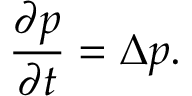Convert formula to latex. <formula><loc_0><loc_0><loc_500><loc_500>{ \frac { \partial p } { \partial t } } = \Delta p .</formula> 